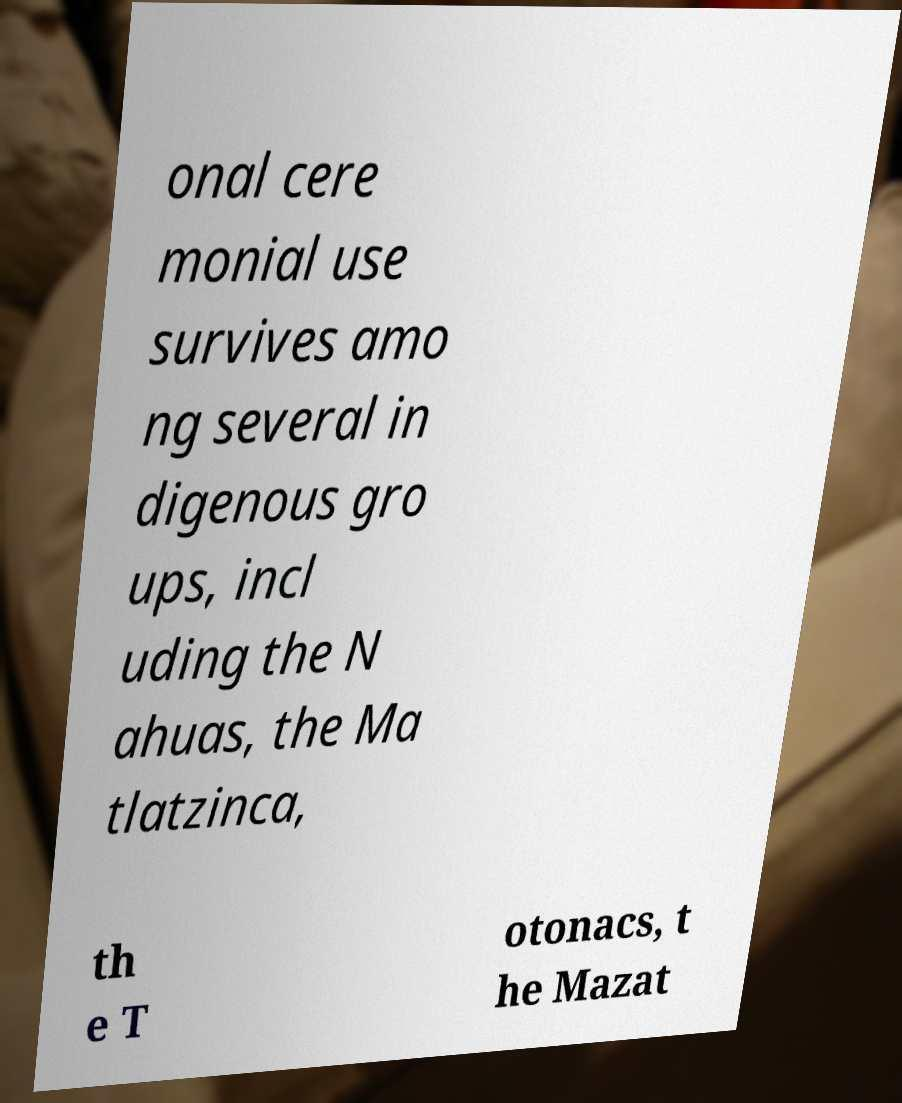Could you assist in decoding the text presented in this image and type it out clearly? onal cere monial use survives amo ng several in digenous gro ups, incl uding the N ahuas, the Ma tlatzinca, th e T otonacs, t he Mazat 